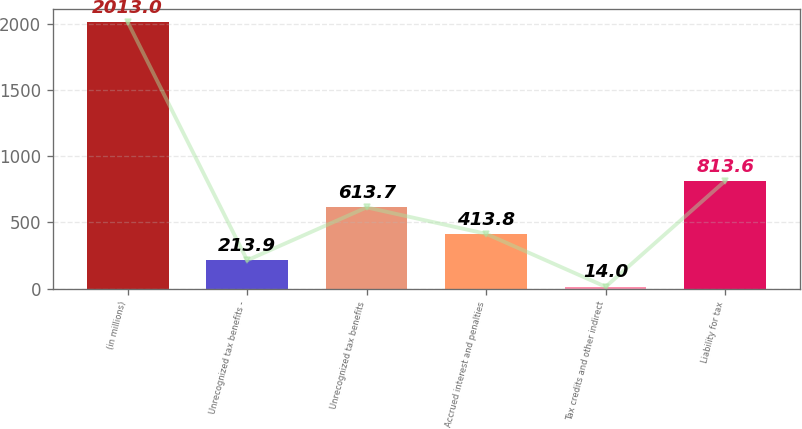Convert chart to OTSL. <chart><loc_0><loc_0><loc_500><loc_500><bar_chart><fcel>(in millions)<fcel>Unrecognized tax benefits -<fcel>Unrecognized tax benefits<fcel>Accrued interest and penalties<fcel>Tax credits and other indirect<fcel>Liability for tax<nl><fcel>2013<fcel>213.9<fcel>613.7<fcel>413.8<fcel>14<fcel>813.6<nl></chart> 